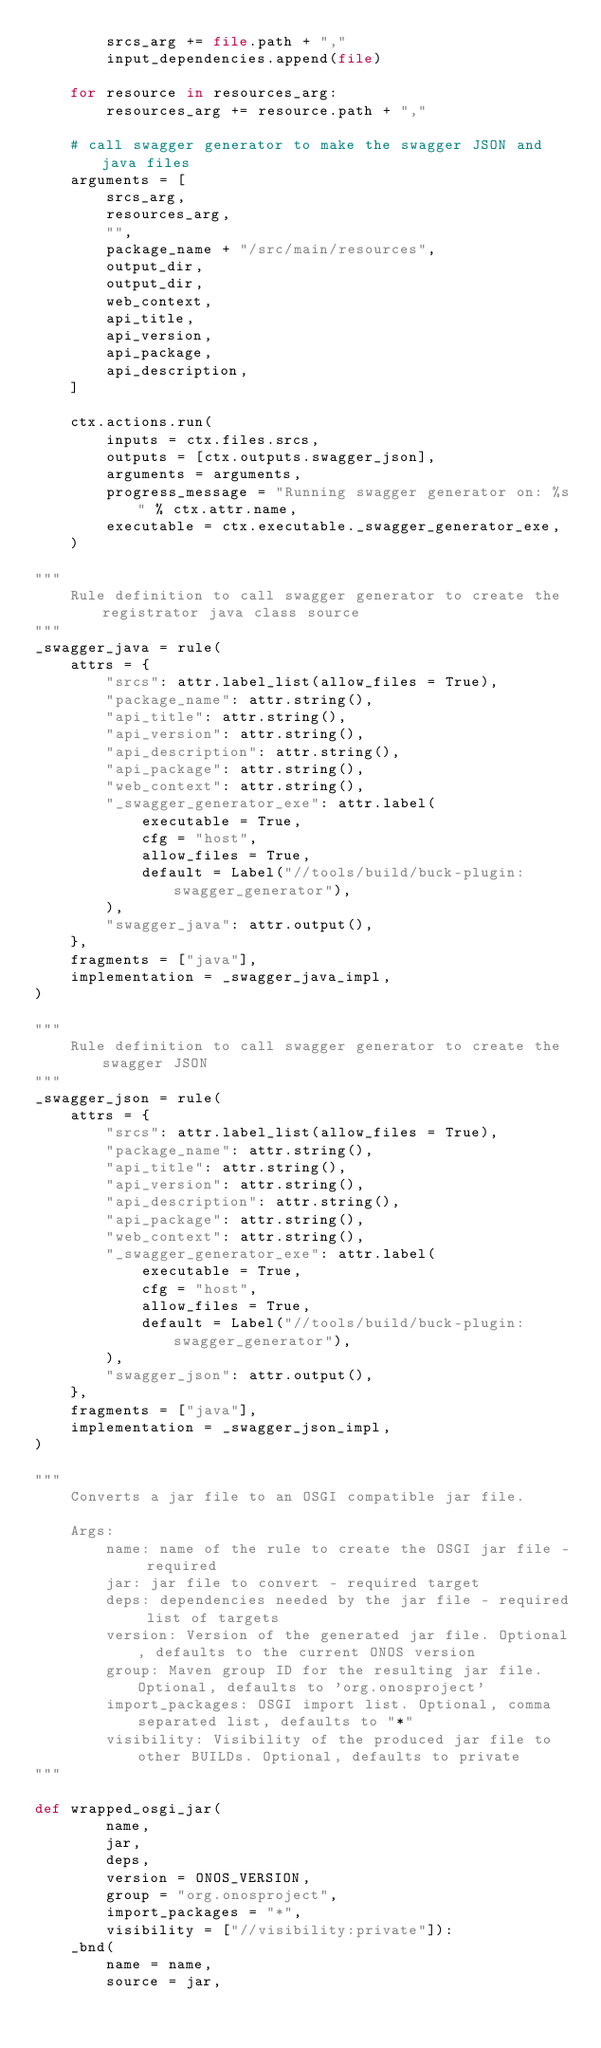Convert code to text. <code><loc_0><loc_0><loc_500><loc_500><_Python_>        srcs_arg += file.path + ","
        input_dependencies.append(file)

    for resource in resources_arg:
        resources_arg += resource.path + ","

    # call swagger generator to make the swagger JSON and java files
    arguments = [
        srcs_arg,
        resources_arg,
        "",
        package_name + "/src/main/resources",
        output_dir,
        output_dir,
        web_context,
        api_title,
        api_version,
        api_package,
        api_description,
    ]

    ctx.actions.run(
        inputs = ctx.files.srcs,
        outputs = [ctx.outputs.swagger_json],
        arguments = arguments,
        progress_message = "Running swagger generator on: %s" % ctx.attr.name,
        executable = ctx.executable._swagger_generator_exe,
    )

"""
    Rule definition to call swagger generator to create the registrator java class source
"""
_swagger_java = rule(
    attrs = {
        "srcs": attr.label_list(allow_files = True),
        "package_name": attr.string(),
        "api_title": attr.string(),
        "api_version": attr.string(),
        "api_description": attr.string(),
        "api_package": attr.string(),
        "web_context": attr.string(),
        "_swagger_generator_exe": attr.label(
            executable = True,
            cfg = "host",
            allow_files = True,
            default = Label("//tools/build/buck-plugin:swagger_generator"),
        ),
        "swagger_java": attr.output(),
    },
    fragments = ["java"],
    implementation = _swagger_java_impl,
)

"""
    Rule definition to call swagger generator to create the swagger JSON
"""
_swagger_json = rule(
    attrs = {
        "srcs": attr.label_list(allow_files = True),
        "package_name": attr.string(),
        "api_title": attr.string(),
        "api_version": attr.string(),
        "api_description": attr.string(),
        "api_package": attr.string(),
        "web_context": attr.string(),
        "_swagger_generator_exe": attr.label(
            executable = True,
            cfg = "host",
            allow_files = True,
            default = Label("//tools/build/buck-plugin:swagger_generator"),
        ),
        "swagger_json": attr.output(),
    },
    fragments = ["java"],
    implementation = _swagger_json_impl,
)

"""
    Converts a jar file to an OSGI compatible jar file.

    Args:
        name: name of the rule to create the OSGI jar file - required
        jar: jar file to convert - required target
        deps: dependencies needed by the jar file - required list of targets
        version: Version of the generated jar file. Optional, defaults to the current ONOS version
        group: Maven group ID for the resulting jar file. Optional, defaults to 'org.onosproject'
        import_packages: OSGI import list. Optional, comma separated list, defaults to "*"
        visibility: Visibility of the produced jar file to other BUILDs. Optional, defaults to private
"""

def wrapped_osgi_jar(
        name,
        jar,
        deps,
        version = ONOS_VERSION,
        group = "org.onosproject",
        import_packages = "*",
        visibility = ["//visibility:private"]):
    _bnd(
        name = name,
        source = jar,</code> 